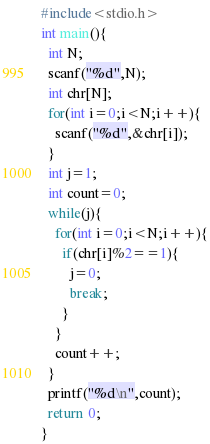Convert code to text. <code><loc_0><loc_0><loc_500><loc_500><_C_>#include<stdio.h>
int main(){
  int N;
  scanf("%d",N);
  int chr[N];
  for(int i=0;i<N;i++){
    scanf("%d",&chr[i]);
  }
  int j=1;
  int count=0;
  while(j){
    for(int i=0;i<N;i++){
      if(chr[i]%2==1){
        j=0;
        break;
      }
    }
    count++;
  }
  printf("%d\n",count);
  return 0;
}</code> 